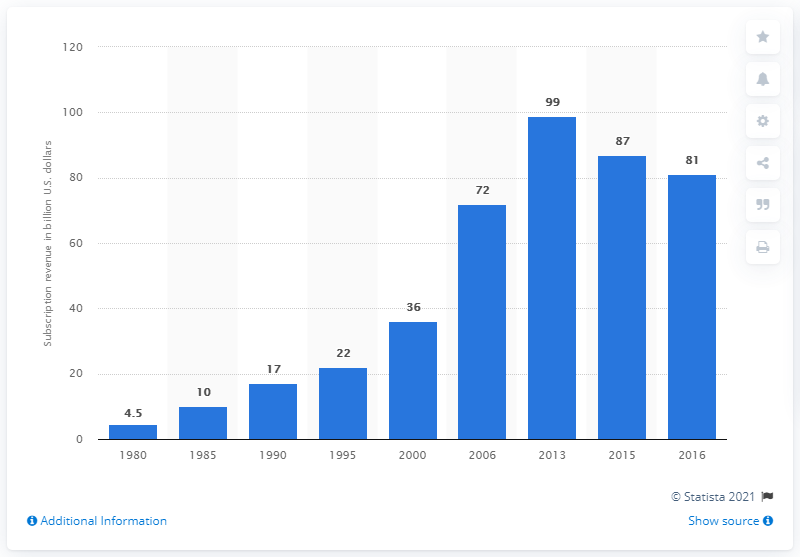List a handful of essential elements in this visual. In 2016, the cable industry generated approximately $81 billion in subscription revenue. In 2013, the cable industry generated approximately $99 million in subscription revenue. 